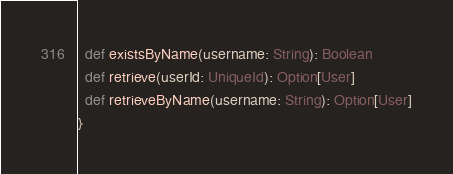Convert code to text. <code><loc_0><loc_0><loc_500><loc_500><_Scala_>  def existsByName(username: String): Boolean
  def retrieve(userId: UniqueId): Option[User]
  def retrieveByName(username: String): Option[User]
}
</code> 